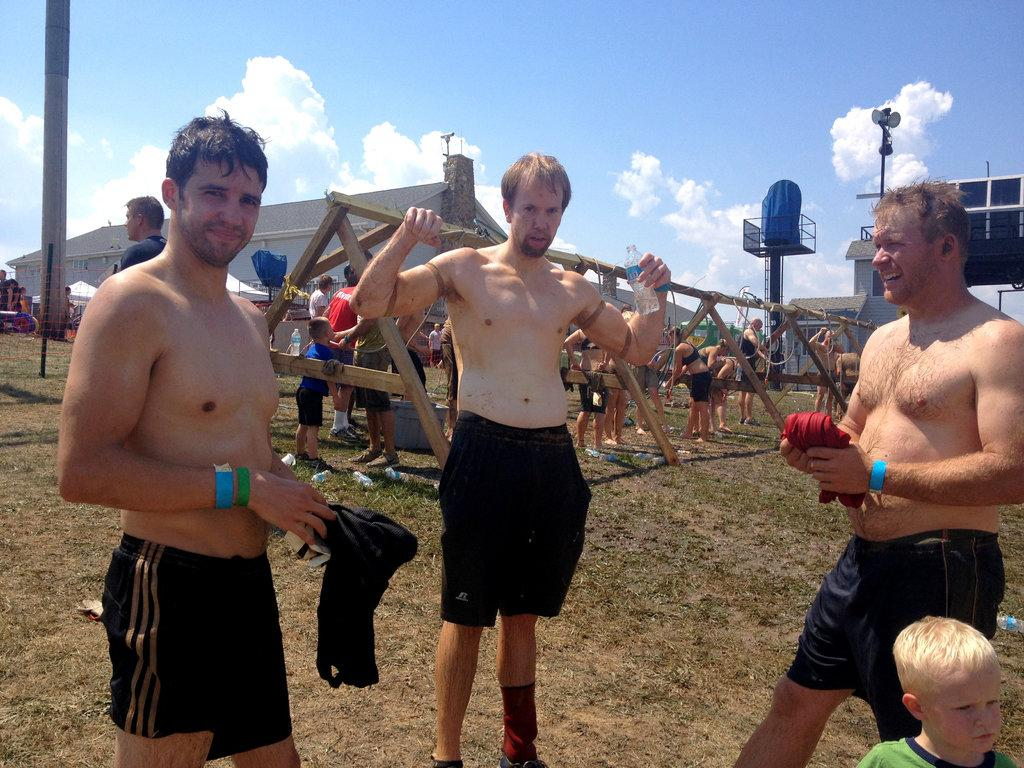How many men are present in the image? There are three men in the image. What else can be seen in the background of the image? There is a boy, a wooden shed, and other people in the background of the image. What type of structure is visible in the background of the image? There are sheds in the background of the image, including a wooden shed. What is the color of the sky in the background of the image? A: The sky is blue in the background of the image. What type of sense can be seen in the image? There is no sense present in the image; it is a visual representation of people and structures. How many times has the wooden shed been folded in the image? The wooden shed is a stationary structure and has not been folded in the image. 